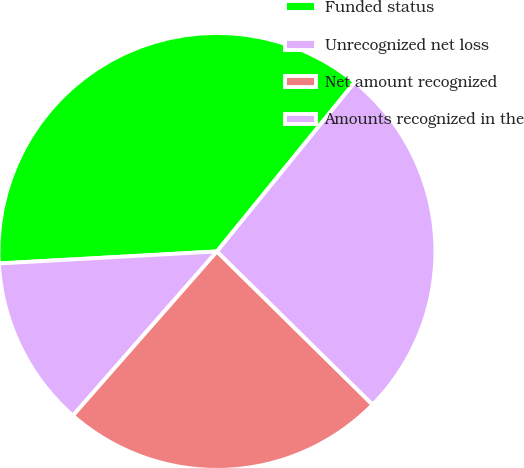Convert chart to OTSL. <chart><loc_0><loc_0><loc_500><loc_500><pie_chart><fcel>Funded status<fcel>Unrecognized net loss<fcel>Net amount recognized<fcel>Amounts recognized in the<nl><fcel>36.75%<fcel>12.66%<fcel>24.09%<fcel>26.5%<nl></chart> 